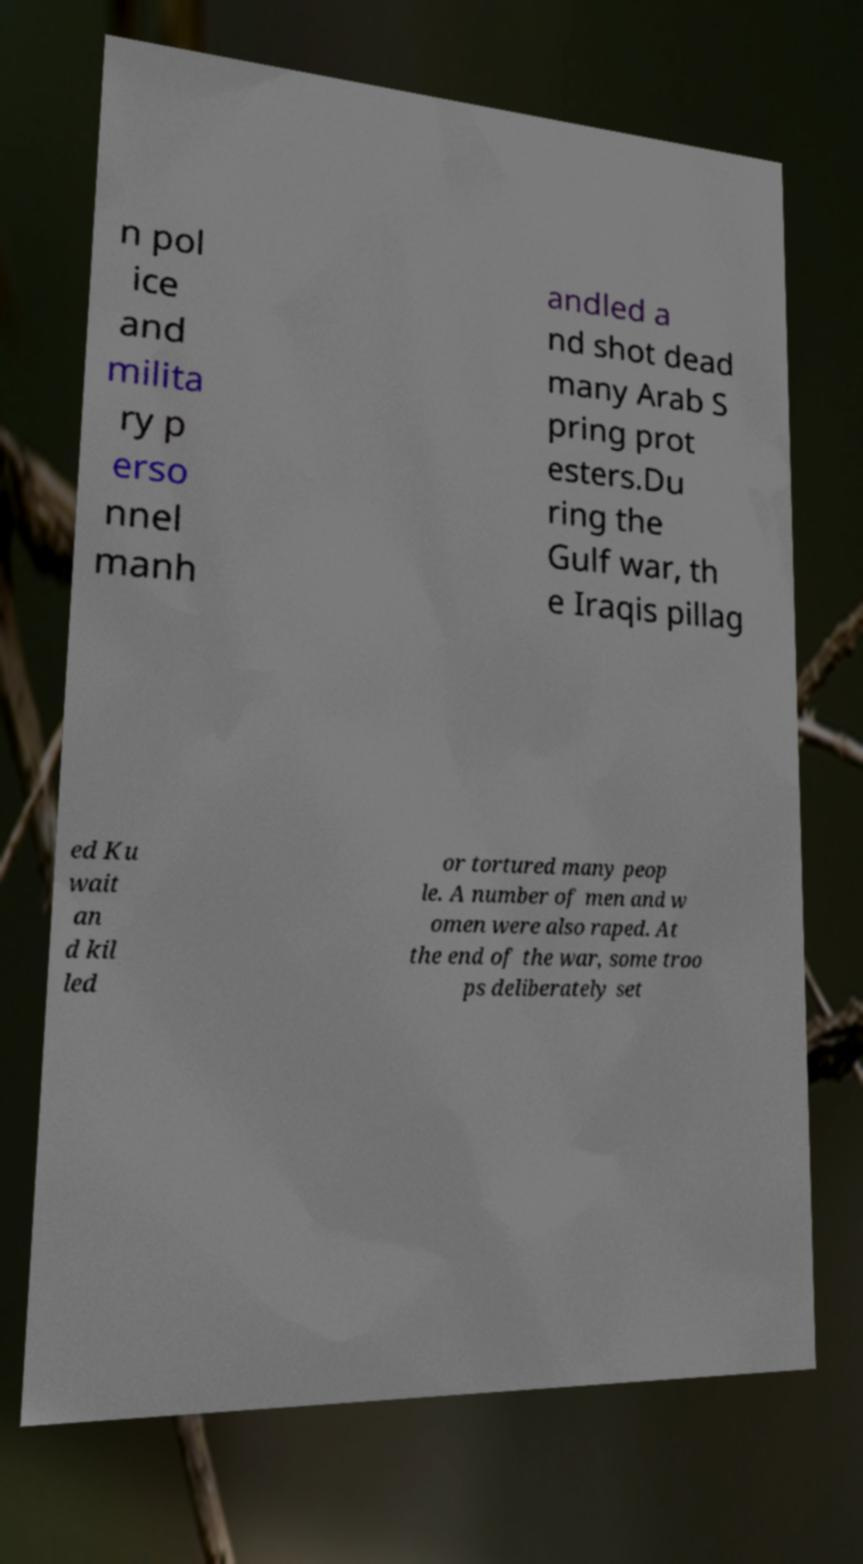Please identify and transcribe the text found in this image. n pol ice and milita ry p erso nnel manh andled a nd shot dead many Arab S pring prot esters.Du ring the Gulf war, th e Iraqis pillag ed Ku wait an d kil led or tortured many peop le. A number of men and w omen were also raped. At the end of the war, some troo ps deliberately set 